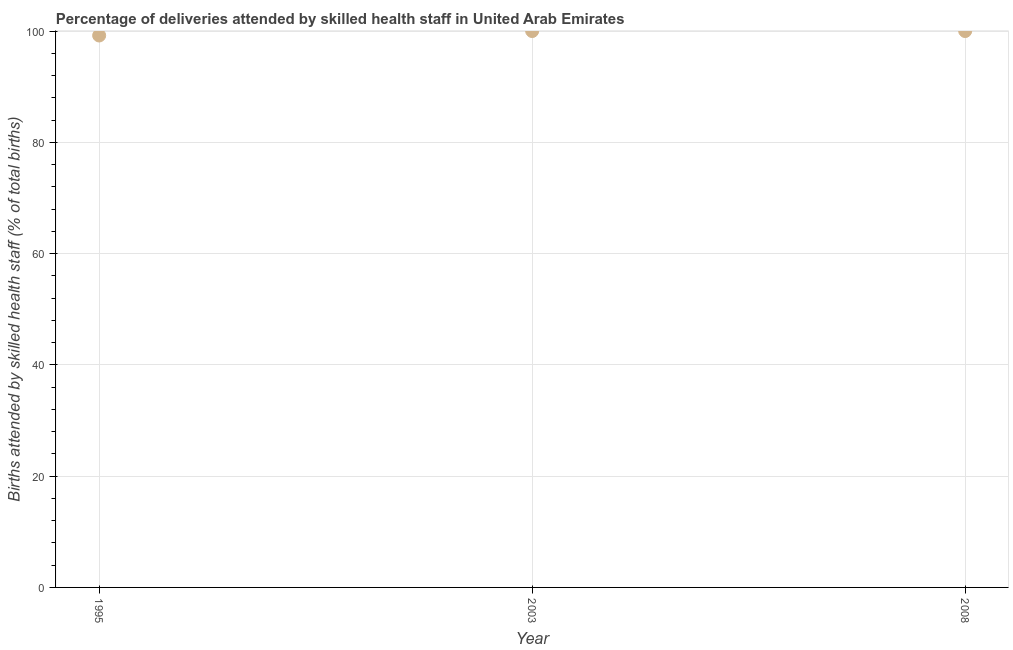What is the number of births attended by skilled health staff in 1995?
Offer a very short reply. 99.2. Across all years, what is the minimum number of births attended by skilled health staff?
Your response must be concise. 99.2. What is the sum of the number of births attended by skilled health staff?
Provide a succinct answer. 299.2. What is the difference between the number of births attended by skilled health staff in 2003 and 2008?
Offer a terse response. 0. What is the average number of births attended by skilled health staff per year?
Your answer should be very brief. 99.73. Do a majority of the years between 2003 and 1995 (inclusive) have number of births attended by skilled health staff greater than 48 %?
Your response must be concise. No. What is the difference between the highest and the second highest number of births attended by skilled health staff?
Your answer should be compact. 0. Is the sum of the number of births attended by skilled health staff in 1995 and 2008 greater than the maximum number of births attended by skilled health staff across all years?
Offer a very short reply. Yes. What is the difference between the highest and the lowest number of births attended by skilled health staff?
Provide a short and direct response. 0.8. In how many years, is the number of births attended by skilled health staff greater than the average number of births attended by skilled health staff taken over all years?
Keep it short and to the point. 2. How many years are there in the graph?
Make the answer very short. 3. Are the values on the major ticks of Y-axis written in scientific E-notation?
Provide a short and direct response. No. What is the title of the graph?
Your response must be concise. Percentage of deliveries attended by skilled health staff in United Arab Emirates. What is the label or title of the X-axis?
Your response must be concise. Year. What is the label or title of the Y-axis?
Make the answer very short. Births attended by skilled health staff (% of total births). What is the Births attended by skilled health staff (% of total births) in 1995?
Provide a short and direct response. 99.2. What is the difference between the Births attended by skilled health staff (% of total births) in 1995 and 2008?
Provide a succinct answer. -0.8. What is the difference between the Births attended by skilled health staff (% of total births) in 2003 and 2008?
Make the answer very short. 0. What is the ratio of the Births attended by skilled health staff (% of total births) in 1995 to that in 2003?
Your answer should be compact. 0.99. What is the ratio of the Births attended by skilled health staff (% of total births) in 1995 to that in 2008?
Provide a succinct answer. 0.99. 